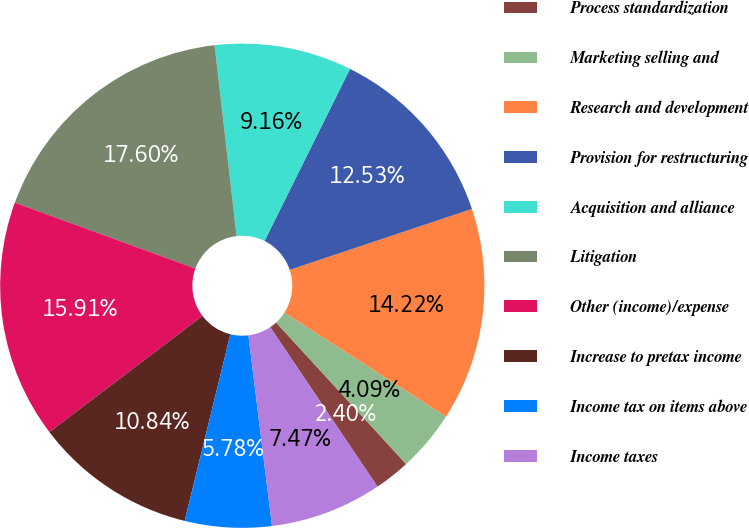<chart> <loc_0><loc_0><loc_500><loc_500><pie_chart><fcel>Process standardization<fcel>Marketing selling and<fcel>Research and development<fcel>Provision for restructuring<fcel>Acquisition and alliance<fcel>Litigation<fcel>Other (income)/expense<fcel>Increase to pretax income<fcel>Income tax on items above<fcel>Income taxes<nl><fcel>2.4%<fcel>4.09%<fcel>14.22%<fcel>12.53%<fcel>9.16%<fcel>17.6%<fcel>15.91%<fcel>10.84%<fcel>5.78%<fcel>7.47%<nl></chart> 